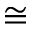Convert formula to latex. <formula><loc_0><loc_0><loc_500><loc_500>\cong</formula> 